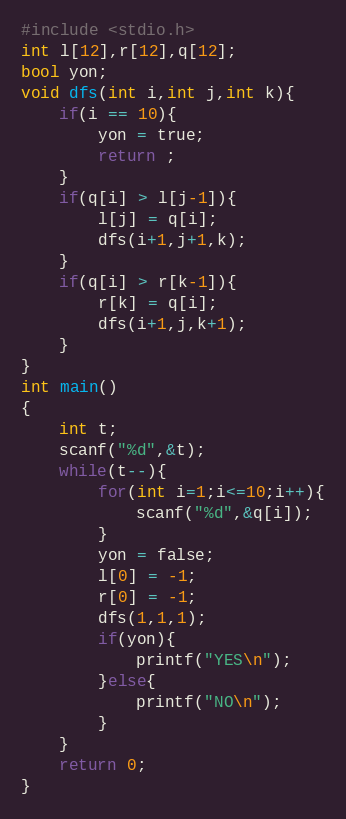Convert code to text. <code><loc_0><loc_0><loc_500><loc_500><_C_>#include <stdio.h>
int l[12],r[12],q[12];
bool yon;
void dfs(int i,int j,int k){
	if(i == 10){
		yon = true;
		return ;
	}
	if(q[i] > l[j-1]){
		l[j] = q[i];
		dfs(i+1,j+1,k);
	}
	if(q[i] > r[k-1]){
		r[k] = q[i];
		dfs(i+1,j,k+1);
	}
}
int main()
{
	int t;
	scanf("%d",&t);
	while(t--){
		for(int i=1;i<=10;i++){
			scanf("%d",&q[i]);
		}
		yon = false;
		l[0] = -1;
		r[0] = -1;
		dfs(1,1,1);
		if(yon){
			printf("YES\n");
		}else{
			printf("NO\n"); 
		}
	}
	return 0;
}</code> 